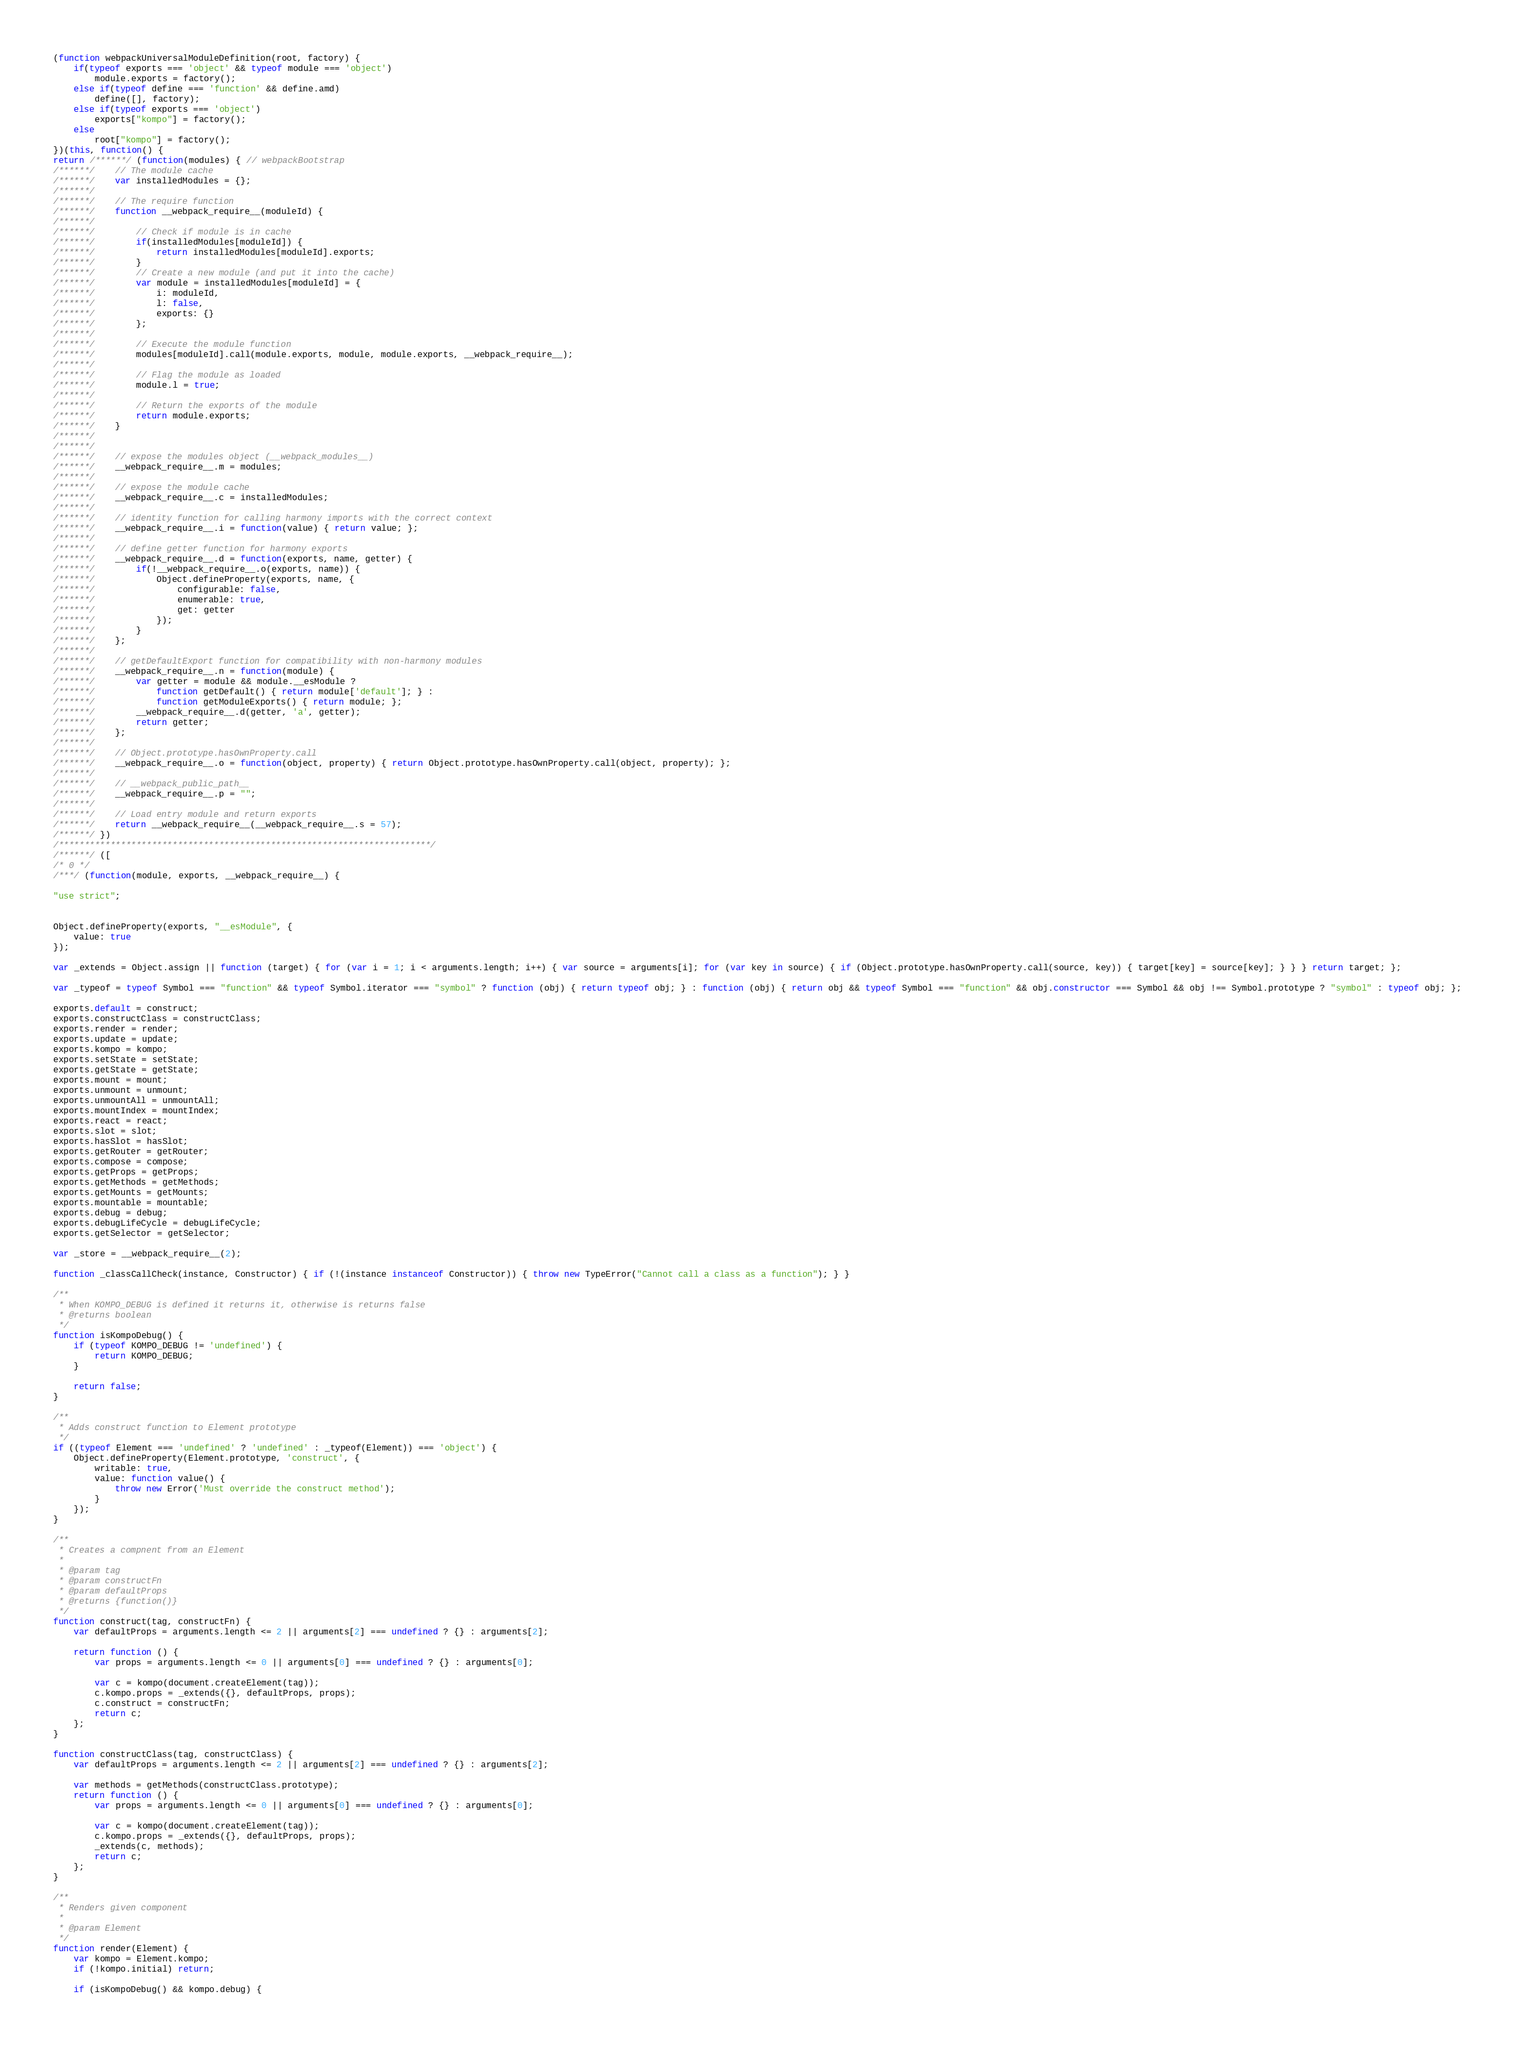Convert code to text. <code><loc_0><loc_0><loc_500><loc_500><_JavaScript_>(function webpackUniversalModuleDefinition(root, factory) {
	if(typeof exports === 'object' && typeof module === 'object')
		module.exports = factory();
	else if(typeof define === 'function' && define.amd)
		define([], factory);
	else if(typeof exports === 'object')
		exports["kompo"] = factory();
	else
		root["kompo"] = factory();
})(this, function() {
return /******/ (function(modules) { // webpackBootstrap
/******/ 	// The module cache
/******/ 	var installedModules = {};
/******/
/******/ 	// The require function
/******/ 	function __webpack_require__(moduleId) {
/******/
/******/ 		// Check if module is in cache
/******/ 		if(installedModules[moduleId]) {
/******/ 			return installedModules[moduleId].exports;
/******/ 		}
/******/ 		// Create a new module (and put it into the cache)
/******/ 		var module = installedModules[moduleId] = {
/******/ 			i: moduleId,
/******/ 			l: false,
/******/ 			exports: {}
/******/ 		};
/******/
/******/ 		// Execute the module function
/******/ 		modules[moduleId].call(module.exports, module, module.exports, __webpack_require__);
/******/
/******/ 		// Flag the module as loaded
/******/ 		module.l = true;
/******/
/******/ 		// Return the exports of the module
/******/ 		return module.exports;
/******/ 	}
/******/
/******/
/******/ 	// expose the modules object (__webpack_modules__)
/******/ 	__webpack_require__.m = modules;
/******/
/******/ 	// expose the module cache
/******/ 	__webpack_require__.c = installedModules;
/******/
/******/ 	// identity function for calling harmony imports with the correct context
/******/ 	__webpack_require__.i = function(value) { return value; };
/******/
/******/ 	// define getter function for harmony exports
/******/ 	__webpack_require__.d = function(exports, name, getter) {
/******/ 		if(!__webpack_require__.o(exports, name)) {
/******/ 			Object.defineProperty(exports, name, {
/******/ 				configurable: false,
/******/ 				enumerable: true,
/******/ 				get: getter
/******/ 			});
/******/ 		}
/******/ 	};
/******/
/******/ 	// getDefaultExport function for compatibility with non-harmony modules
/******/ 	__webpack_require__.n = function(module) {
/******/ 		var getter = module && module.__esModule ?
/******/ 			function getDefault() { return module['default']; } :
/******/ 			function getModuleExports() { return module; };
/******/ 		__webpack_require__.d(getter, 'a', getter);
/******/ 		return getter;
/******/ 	};
/******/
/******/ 	// Object.prototype.hasOwnProperty.call
/******/ 	__webpack_require__.o = function(object, property) { return Object.prototype.hasOwnProperty.call(object, property); };
/******/
/******/ 	// __webpack_public_path__
/******/ 	__webpack_require__.p = "";
/******/
/******/ 	// Load entry module and return exports
/******/ 	return __webpack_require__(__webpack_require__.s = 57);
/******/ })
/************************************************************************/
/******/ ([
/* 0 */
/***/ (function(module, exports, __webpack_require__) {

"use strict";


Object.defineProperty(exports, "__esModule", {
    value: true
});

var _extends = Object.assign || function (target) { for (var i = 1; i < arguments.length; i++) { var source = arguments[i]; for (var key in source) { if (Object.prototype.hasOwnProperty.call(source, key)) { target[key] = source[key]; } } } return target; };

var _typeof = typeof Symbol === "function" && typeof Symbol.iterator === "symbol" ? function (obj) { return typeof obj; } : function (obj) { return obj && typeof Symbol === "function" && obj.constructor === Symbol && obj !== Symbol.prototype ? "symbol" : typeof obj; };

exports.default = construct;
exports.constructClass = constructClass;
exports.render = render;
exports.update = update;
exports.kompo = kompo;
exports.setState = setState;
exports.getState = getState;
exports.mount = mount;
exports.unmount = unmount;
exports.unmountAll = unmountAll;
exports.mountIndex = mountIndex;
exports.react = react;
exports.slot = slot;
exports.hasSlot = hasSlot;
exports.getRouter = getRouter;
exports.compose = compose;
exports.getProps = getProps;
exports.getMethods = getMethods;
exports.getMounts = getMounts;
exports.mountable = mountable;
exports.debug = debug;
exports.debugLifeCycle = debugLifeCycle;
exports.getSelector = getSelector;

var _store = __webpack_require__(2);

function _classCallCheck(instance, Constructor) { if (!(instance instanceof Constructor)) { throw new TypeError("Cannot call a class as a function"); } }

/**
 * When KOMPO_DEBUG is defined it returns it, otherwise is returns false
 * @returns boolean
 */
function isKompoDebug() {
    if (typeof KOMPO_DEBUG != 'undefined') {
        return KOMPO_DEBUG;
    }

    return false;
}

/**
 * Adds construct function to Element prototype
 */
if ((typeof Element === 'undefined' ? 'undefined' : _typeof(Element)) === 'object') {
    Object.defineProperty(Element.prototype, 'construct', {
        writable: true,
        value: function value() {
            throw new Error('Must override the construct method');
        }
    });
}

/**
 * Creates a compnent from an Element
 *
 * @param tag
 * @param constructFn
 * @param defaultProps
 * @returns {function()}
 */
function construct(tag, constructFn) {
    var defaultProps = arguments.length <= 2 || arguments[2] === undefined ? {} : arguments[2];

    return function () {
        var props = arguments.length <= 0 || arguments[0] === undefined ? {} : arguments[0];

        var c = kompo(document.createElement(tag));
        c.kompo.props = _extends({}, defaultProps, props);
        c.construct = constructFn;
        return c;
    };
}

function constructClass(tag, constructClass) {
    var defaultProps = arguments.length <= 2 || arguments[2] === undefined ? {} : arguments[2];

    var methods = getMethods(constructClass.prototype);
    return function () {
        var props = arguments.length <= 0 || arguments[0] === undefined ? {} : arguments[0];

        var c = kompo(document.createElement(tag));
        c.kompo.props = _extends({}, defaultProps, props);
        _extends(c, methods);
        return c;
    };
}

/**
 * Renders given component
 *
 * @param Element
 */
function render(Element) {
    var kompo = Element.kompo;
    if (!kompo.initial) return;

    if (isKompoDebug() && kompo.debug) {</code> 